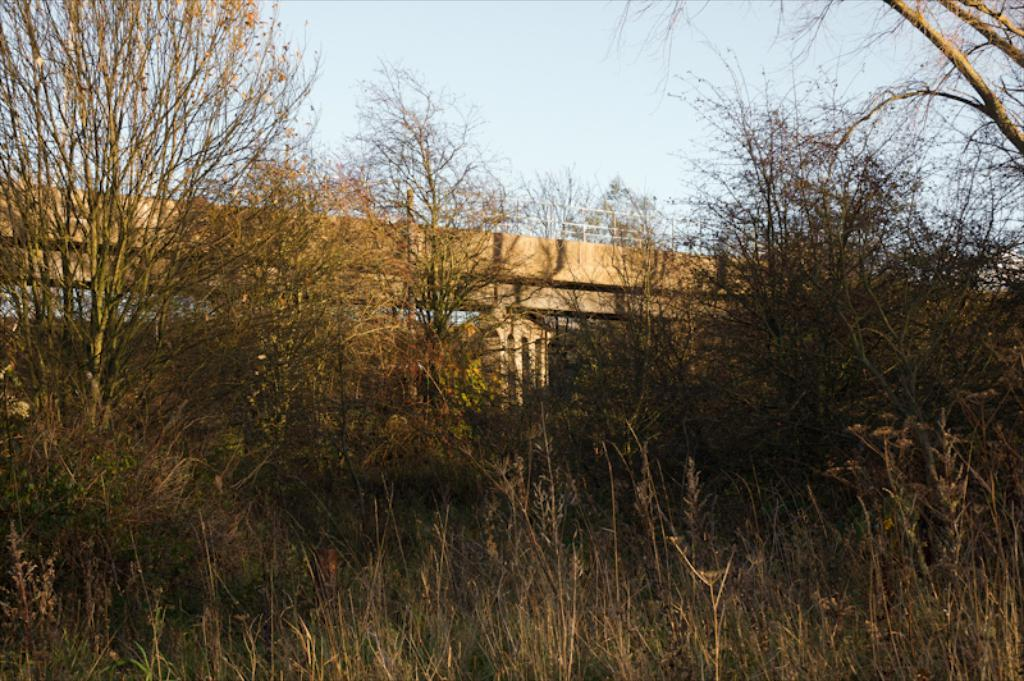What type of vegetation can be seen in the image? There are trees in the image. What structure is visible behind the trees? There is a bridge behind the trees. What part of the natural environment is visible in the image? The sky is visible in the background of the image. How many clocks are hanging from the trees in the image? There are no clocks hanging from the trees in the image. What type of story is being told by the trees and bridge in the image? The image does not depict a story; it is a visual representation of trees, a bridge, and the sky. 